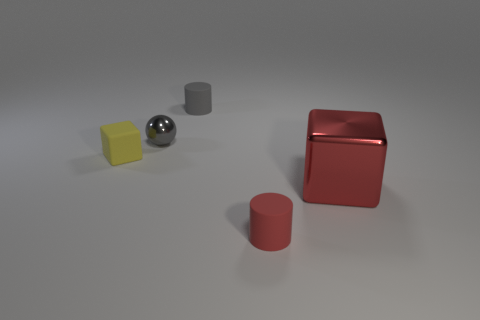Add 3 tiny matte cylinders. How many objects exist? 8 Subtract all spheres. How many objects are left? 4 Subtract all big gray metallic blocks. Subtract all gray metallic objects. How many objects are left? 4 Add 4 small yellow objects. How many small yellow objects are left? 5 Add 2 brown matte blocks. How many brown matte blocks exist? 2 Subtract 0 cyan spheres. How many objects are left? 5 